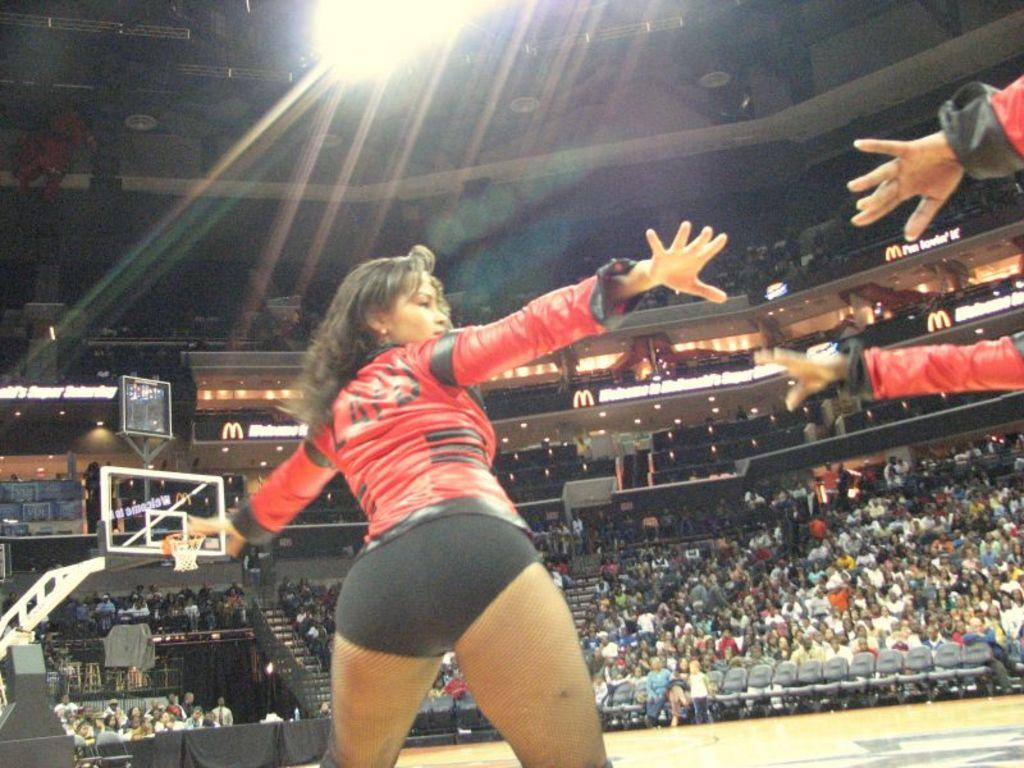How many groups of people can be seen in the image? There are multiple groups of people in the image. What is the purpose of the screen in the image? The purpose of the screen in the image is not specified, but it could be used for displaying information or visuals. What type of lighting is present in the image? There are lights in the image, but their specific type or purpose is not mentioned. What architectural feature is present in the image? There are stairs in the image. What type of furniture is present in the image? There are chairs in the image. What type of vest is being worn by the person in the picture? There is no person wearing a vest in the image; the image features multiple groups of people. What type of picture is being displayed on the screen in the image? There is no picture displayed on the screen in the image; the purpose of the screen is not specified. 